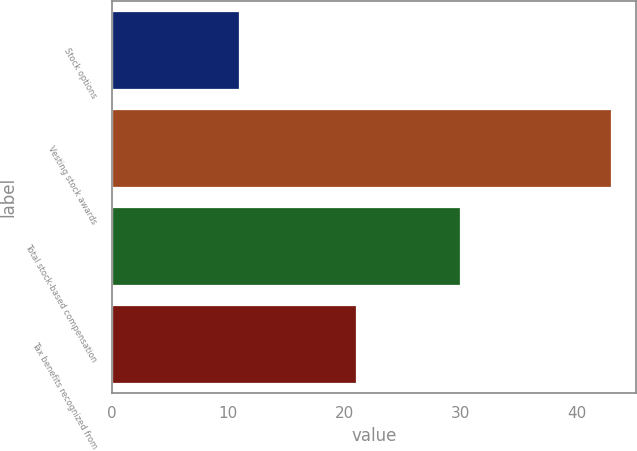Convert chart. <chart><loc_0><loc_0><loc_500><loc_500><bar_chart><fcel>Stock options<fcel>Vesting stock awards<fcel>Total stock-based compensation<fcel>Tax benefits recognized from<nl><fcel>11<fcel>43<fcel>30<fcel>21<nl></chart> 